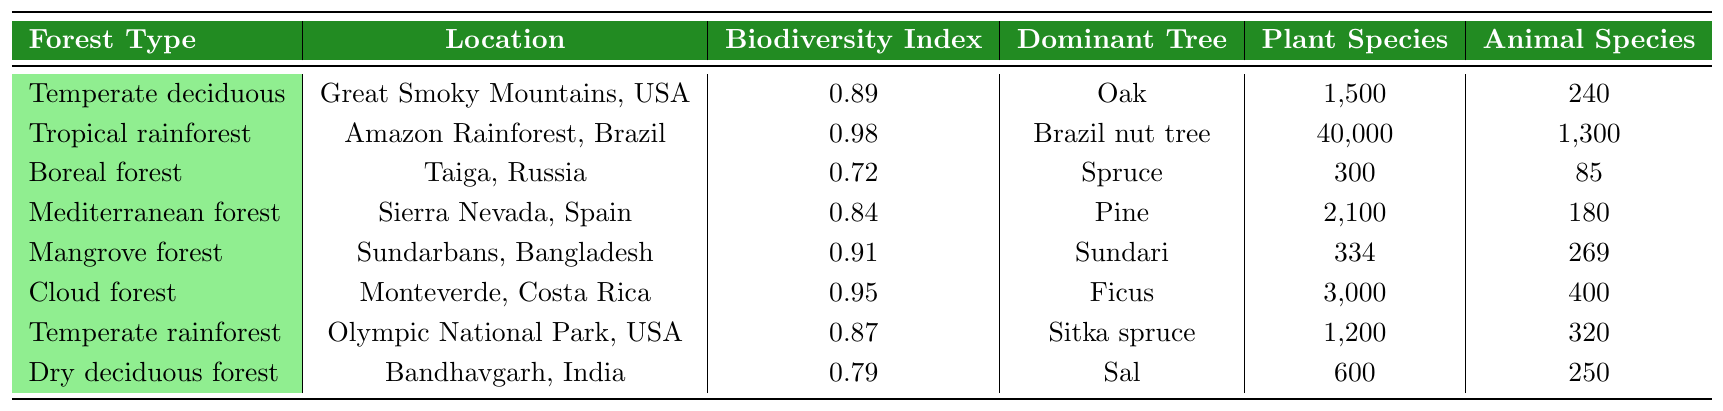What is the biodiversity index of the Tropical rainforest? The biodiversity index is directly listed in the table under the "Biodiversity Index" column for the "Tropical rainforest." The value is 0.98.
Answer: 0.98 Which forest type has the highest number of animal species? By comparing the "Animal Species" column, the "Tropical rainforest" has the highest number of animal species at 1,300.
Answer: Tropical rainforest Is the dominant tree species in the Dry deciduous forest Sal? The table states that the dominant tree species for the "Dry deciduous forest" is "Sal," confirming the statement is true.
Answer: Yes What is the difference in the number of plant species between the Temperate rainforest and the Boreal forest? The number of plant species in the Temperate rainforest is 1,200, and in the Boreal forest, it is 300. The difference is 1,200 - 300 = 900.
Answer: 900 What is the total number of plant species across all forest types? To find the total, sum the values in the "Plant Species" column: 1,500 + 40,000 + 300 + 2,100 + 334 + 3,000 + 1,200 + 600 = 48,034.
Answer: 48,034 Which forest type has a biodiversity index less than 0.80? By reviewing the "Biodiversity Index" column, the Boreal forest (0.72) and Dry deciduous forest (0.79) both have values less than 0.80.
Answer: Boreal forest and Dry deciduous forest What is the average biodiversity index of the Mediterranean forest and the Cloud forest? The biodiversity index for the Mediterranean forest is 0.84 and for the Cloud forest is 0.95. The average is (0.84 + 0.95) / 2 = 0.895.
Answer: 0.895 Which forest type located in the USA has a biodiversity index greater than 0.85? The table shows that the "Temperate deciduous forest" (0.89) and "Temperate rainforest" (0.87) are both located in the USA and have biodiversity indices greater than 0.85.
Answer: Temperate deciduous forest and Temperate rainforest How many more plant species are in the Tropical rainforest compared to the Mangrove forest? The Tropical rainforest has 40,000 plant species, and the Mangrove forest has 334. The difference is 40,000 - 334 = 39,666.
Answer: 39,666 Is it true that the Mediterranean forest has more animal species than the Mangrove forest? The Mediterranean forest has 180 animal species, and the Mangrove forest has 269. Since 180 is less than 269, the statement is false.
Answer: No 